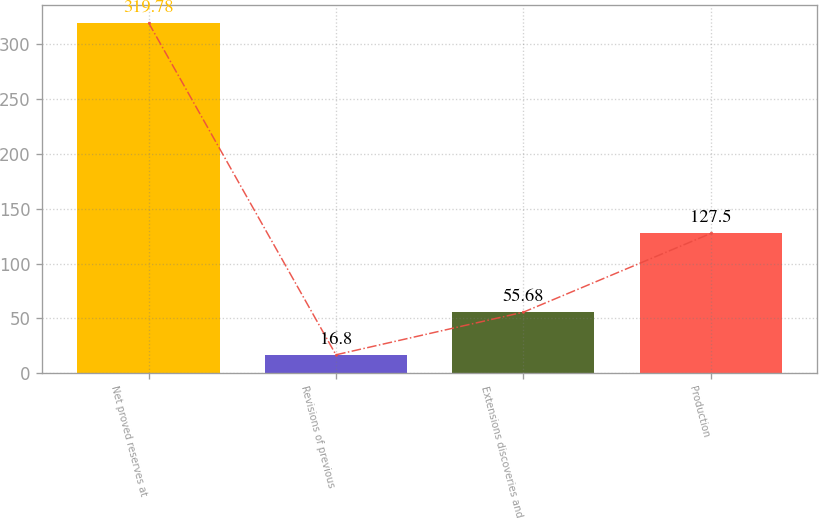Convert chart to OTSL. <chart><loc_0><loc_0><loc_500><loc_500><bar_chart><fcel>Net proved reserves at<fcel>Revisions of previous<fcel>Extensions discoveries and<fcel>Production<nl><fcel>319.78<fcel>16.8<fcel>55.68<fcel>127.5<nl></chart> 